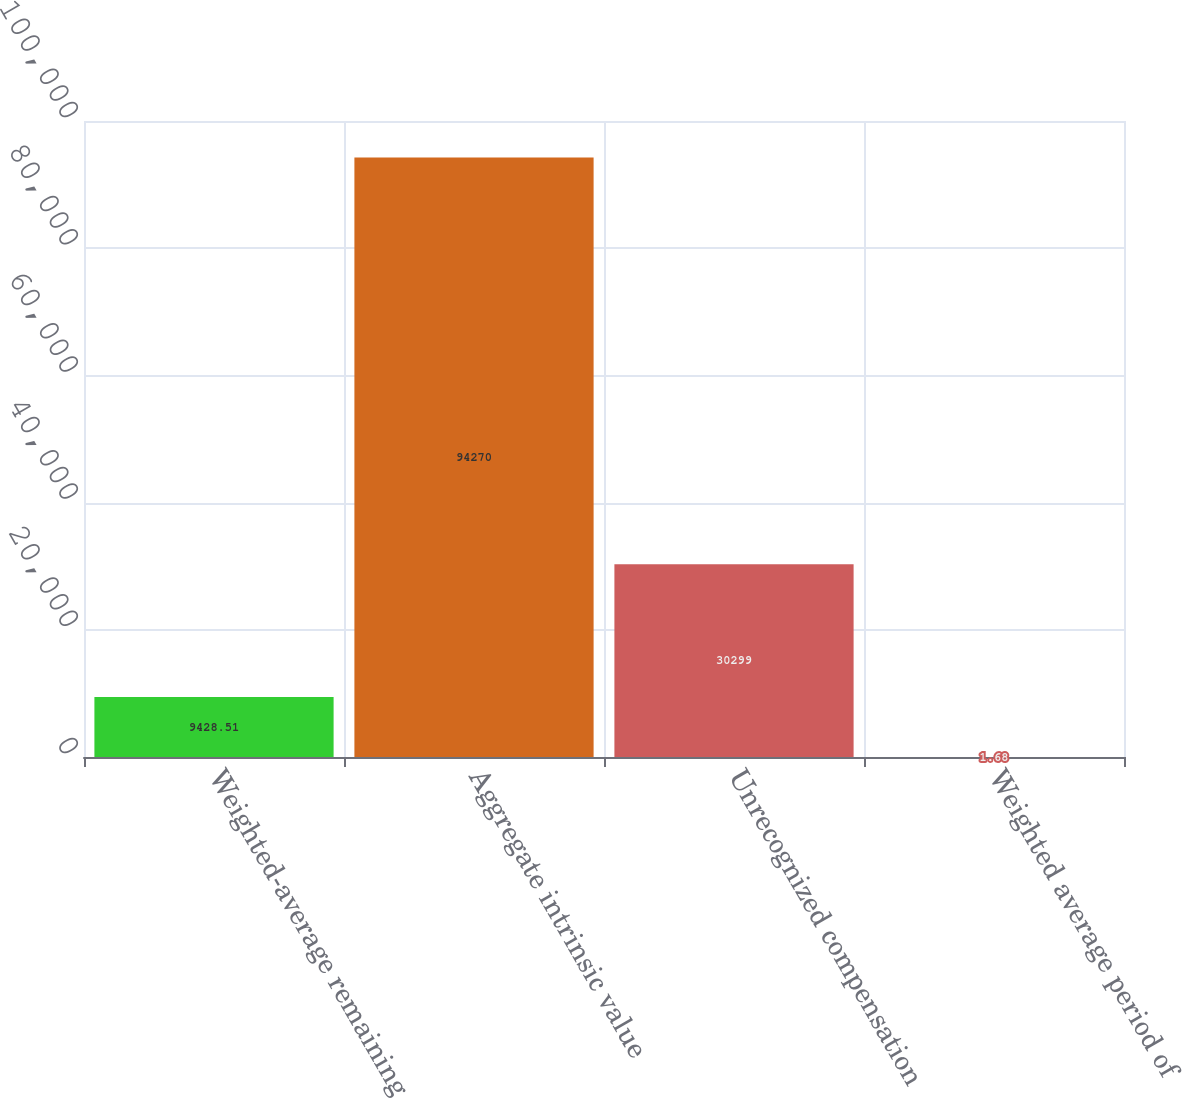Convert chart. <chart><loc_0><loc_0><loc_500><loc_500><bar_chart><fcel>Weighted-average remaining<fcel>Aggregate intrinsic value<fcel>Unrecognized compensation<fcel>Weighted average period of<nl><fcel>9428.51<fcel>94270<fcel>30299<fcel>1.68<nl></chart> 